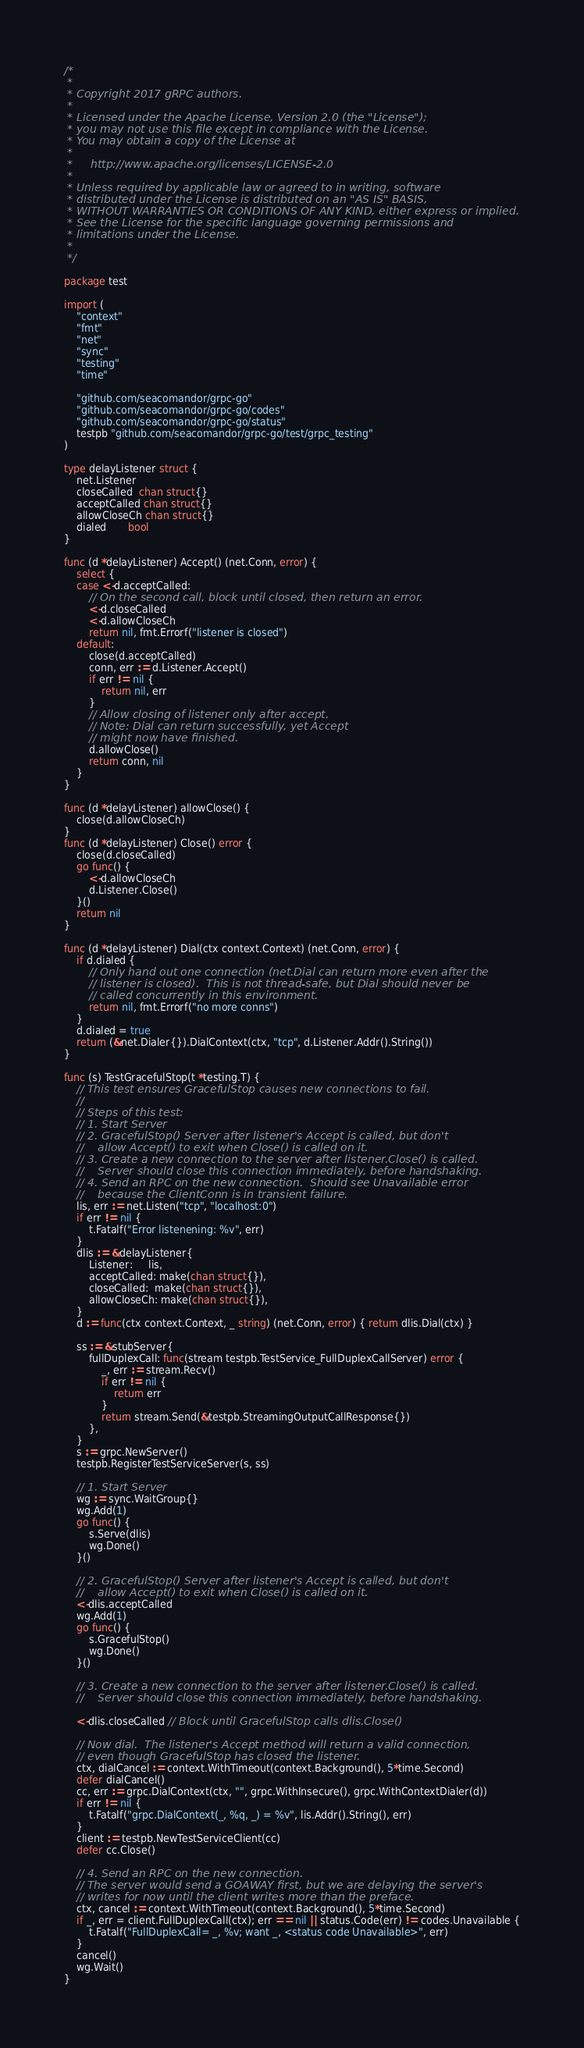<code> <loc_0><loc_0><loc_500><loc_500><_Go_>/*
 *
 * Copyright 2017 gRPC authors.
 *
 * Licensed under the Apache License, Version 2.0 (the "License");
 * you may not use this file except in compliance with the License.
 * You may obtain a copy of the License at
 *
 *     http://www.apache.org/licenses/LICENSE-2.0
 *
 * Unless required by applicable law or agreed to in writing, software
 * distributed under the License is distributed on an "AS IS" BASIS,
 * WITHOUT WARRANTIES OR CONDITIONS OF ANY KIND, either express or implied.
 * See the License for the specific language governing permissions and
 * limitations under the License.
 *
 */

package test

import (
	"context"
	"fmt"
	"net"
	"sync"
	"testing"
	"time"

	"github.com/seacomandor/grpc-go"
	"github.com/seacomandor/grpc-go/codes"
	"github.com/seacomandor/grpc-go/status"
	testpb "github.com/seacomandor/grpc-go/test/grpc_testing"
)

type delayListener struct {
	net.Listener
	closeCalled  chan struct{}
	acceptCalled chan struct{}
	allowCloseCh chan struct{}
	dialed       bool
}

func (d *delayListener) Accept() (net.Conn, error) {
	select {
	case <-d.acceptCalled:
		// On the second call, block until closed, then return an error.
		<-d.closeCalled
		<-d.allowCloseCh
		return nil, fmt.Errorf("listener is closed")
	default:
		close(d.acceptCalled)
		conn, err := d.Listener.Accept()
		if err != nil {
			return nil, err
		}
		// Allow closing of listener only after accept.
		// Note: Dial can return successfully, yet Accept
		// might now have finished.
		d.allowClose()
		return conn, nil
	}
}

func (d *delayListener) allowClose() {
	close(d.allowCloseCh)
}
func (d *delayListener) Close() error {
	close(d.closeCalled)
	go func() {
		<-d.allowCloseCh
		d.Listener.Close()
	}()
	return nil
}

func (d *delayListener) Dial(ctx context.Context) (net.Conn, error) {
	if d.dialed {
		// Only hand out one connection (net.Dial can return more even after the
		// listener is closed).  This is not thread-safe, but Dial should never be
		// called concurrently in this environment.
		return nil, fmt.Errorf("no more conns")
	}
	d.dialed = true
	return (&net.Dialer{}).DialContext(ctx, "tcp", d.Listener.Addr().String())
}

func (s) TestGracefulStop(t *testing.T) {
	// This test ensures GracefulStop causes new connections to fail.
	//
	// Steps of this test:
	// 1. Start Server
	// 2. GracefulStop() Server after listener's Accept is called, but don't
	//    allow Accept() to exit when Close() is called on it.
	// 3. Create a new connection to the server after listener.Close() is called.
	//    Server should close this connection immediately, before handshaking.
	// 4. Send an RPC on the new connection.  Should see Unavailable error
	//    because the ClientConn is in transient failure.
	lis, err := net.Listen("tcp", "localhost:0")
	if err != nil {
		t.Fatalf("Error listenening: %v", err)
	}
	dlis := &delayListener{
		Listener:     lis,
		acceptCalled: make(chan struct{}),
		closeCalled:  make(chan struct{}),
		allowCloseCh: make(chan struct{}),
	}
	d := func(ctx context.Context, _ string) (net.Conn, error) { return dlis.Dial(ctx) }

	ss := &stubServer{
		fullDuplexCall: func(stream testpb.TestService_FullDuplexCallServer) error {
			_, err := stream.Recv()
			if err != nil {
				return err
			}
			return stream.Send(&testpb.StreamingOutputCallResponse{})
		},
	}
	s := grpc.NewServer()
	testpb.RegisterTestServiceServer(s, ss)

	// 1. Start Server
	wg := sync.WaitGroup{}
	wg.Add(1)
	go func() {
		s.Serve(dlis)
		wg.Done()
	}()

	// 2. GracefulStop() Server after listener's Accept is called, but don't
	//    allow Accept() to exit when Close() is called on it.
	<-dlis.acceptCalled
	wg.Add(1)
	go func() {
		s.GracefulStop()
		wg.Done()
	}()

	// 3. Create a new connection to the server after listener.Close() is called.
	//    Server should close this connection immediately, before handshaking.

	<-dlis.closeCalled // Block until GracefulStop calls dlis.Close()

	// Now dial.  The listener's Accept method will return a valid connection,
	// even though GracefulStop has closed the listener.
	ctx, dialCancel := context.WithTimeout(context.Background(), 5*time.Second)
	defer dialCancel()
	cc, err := grpc.DialContext(ctx, "", grpc.WithInsecure(), grpc.WithContextDialer(d))
	if err != nil {
		t.Fatalf("grpc.DialContext(_, %q, _) = %v", lis.Addr().String(), err)
	}
	client := testpb.NewTestServiceClient(cc)
	defer cc.Close()

	// 4. Send an RPC on the new connection.
	// The server would send a GOAWAY first, but we are delaying the server's
	// writes for now until the client writes more than the preface.
	ctx, cancel := context.WithTimeout(context.Background(), 5*time.Second)
	if _, err = client.FullDuplexCall(ctx); err == nil || status.Code(err) != codes.Unavailable {
		t.Fatalf("FullDuplexCall= _, %v; want _, <status code Unavailable>", err)
	}
	cancel()
	wg.Wait()
}
</code> 